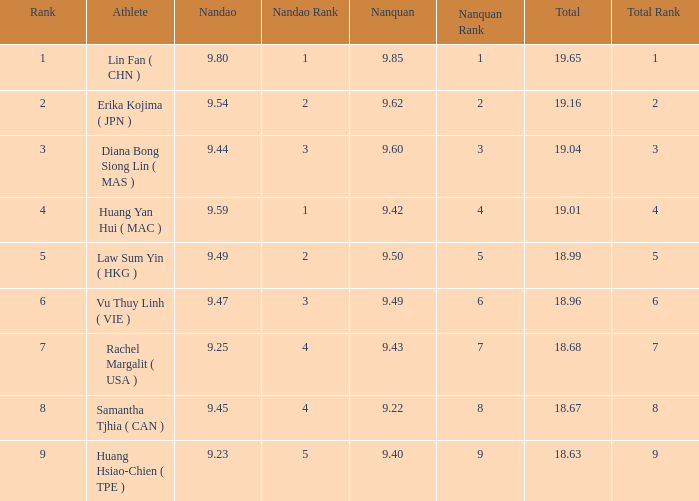Which Nanquan has a Nandao larger than 9.49, and a Rank of 4? 9.42. 